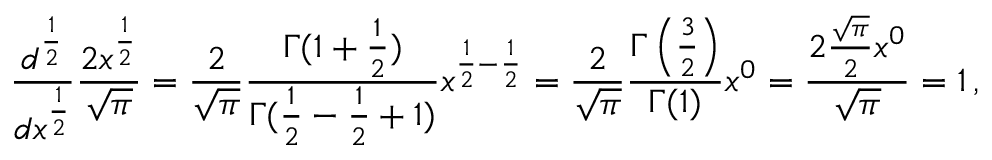<formula> <loc_0><loc_0><loc_500><loc_500>{ \frac { d ^ { \frac { 1 } { 2 } } } { d x ^ { \frac { 1 } { 2 } } } } { \frac { 2 x ^ { \frac { 1 } { 2 } } } { \sqrt { \pi } } } = { \frac { 2 } { \sqrt { \pi } } } { \frac { \Gamma ( 1 + { \frac { 1 } { 2 } } ) } { \Gamma ( { \frac { 1 } { 2 } } - { \frac { 1 } { 2 } } + 1 ) } } x ^ { { \frac { 1 } { 2 } } - { \frac { 1 } { 2 } } } = { \frac { 2 } { \sqrt { \pi } } } { \frac { \Gamma \left ( { \frac { 3 } { 2 } } \right ) } { \Gamma ( 1 ) } } x ^ { 0 } = { \frac { 2 { \frac { \sqrt { \pi } } { 2 } } x ^ { 0 } } { \sqrt { \pi } } } = 1 \, ,</formula> 